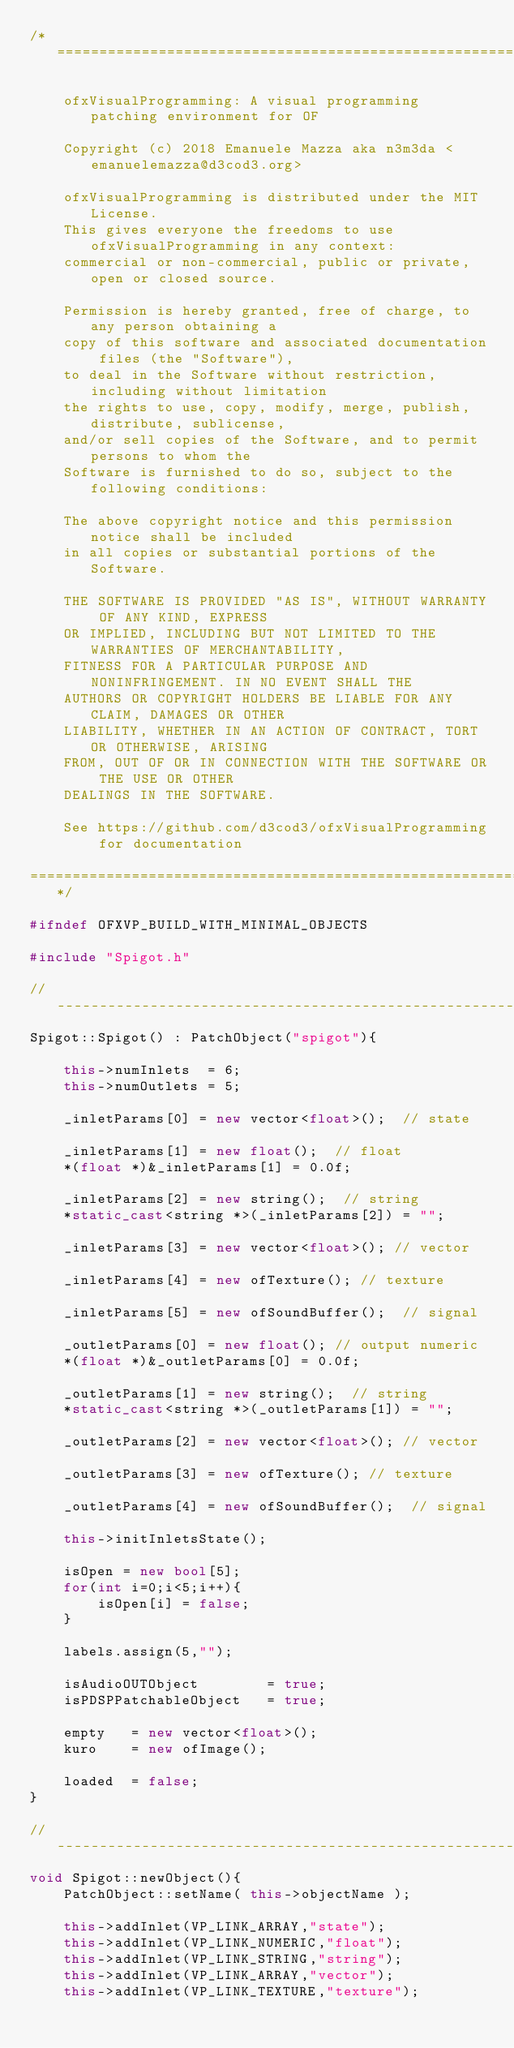<code> <loc_0><loc_0><loc_500><loc_500><_C++_>/*==============================================================================

    ofxVisualProgramming: A visual programming patching environment for OF

    Copyright (c) 2018 Emanuele Mazza aka n3m3da <emanuelemazza@d3cod3.org>

    ofxVisualProgramming is distributed under the MIT License.
    This gives everyone the freedoms to use ofxVisualProgramming in any context:
    commercial or non-commercial, public or private, open or closed source.

    Permission is hereby granted, free of charge, to any person obtaining a
    copy of this software and associated documentation files (the "Software"),
    to deal in the Software without restriction, including without limitation
    the rights to use, copy, modify, merge, publish, distribute, sublicense,
    and/or sell copies of the Software, and to permit persons to whom the
    Software is furnished to do so, subject to the following conditions:

    The above copyright notice and this permission notice shall be included
    in all copies or substantial portions of the Software.

    THE SOFTWARE IS PROVIDED "AS IS", WITHOUT WARRANTY OF ANY KIND, EXPRESS
    OR IMPLIED, INCLUDING BUT NOT LIMITED TO THE WARRANTIES OF MERCHANTABILITY,
    FITNESS FOR A PARTICULAR PURPOSE AND NONINFRINGEMENT. IN NO EVENT SHALL THE
    AUTHORS OR COPYRIGHT HOLDERS BE LIABLE FOR ANY CLAIM, DAMAGES OR OTHER
    LIABILITY, WHETHER IN AN ACTION OF CONTRACT, TORT OR OTHERWISE, ARISING
    FROM, OUT OF OR IN CONNECTION WITH THE SOFTWARE OR THE USE OR OTHER
    DEALINGS IN THE SOFTWARE.

    See https://github.com/d3cod3/ofxVisualProgramming for documentation

==============================================================================*/

#ifndef OFXVP_BUILD_WITH_MINIMAL_OBJECTS

#include "Spigot.h"

//--------------------------------------------------------------
Spigot::Spigot() : PatchObject("spigot"){

    this->numInlets  = 6;
    this->numOutlets = 5;

    _inletParams[0] = new vector<float>();  // state

    _inletParams[1] = new float();  // float
    *(float *)&_inletParams[1] = 0.0f;

    _inletParams[2] = new string();  // string
    *static_cast<string *>(_inletParams[2]) = "";

    _inletParams[3] = new vector<float>(); // vector

    _inletParams[4] = new ofTexture(); // texture

    _inletParams[5] = new ofSoundBuffer();  // signal

    _outletParams[0] = new float(); // output numeric
    *(float *)&_outletParams[0] = 0.0f;

    _outletParams[1] = new string();  // string
    *static_cast<string *>(_outletParams[1]) = "";

    _outletParams[2] = new vector<float>(); // vector

    _outletParams[3] = new ofTexture(); // texture

    _outletParams[4] = new ofSoundBuffer();  // signal

    this->initInletsState();

    isOpen = new bool[5];
    for(int i=0;i<5;i++){
        isOpen[i] = false;
    }

    labels.assign(5,"");

    isAudioOUTObject        = true;
    isPDSPPatchableObject   = true;

    empty   = new vector<float>();
    kuro    = new ofImage();

    loaded  = false;
}

//--------------------------------------------------------------
void Spigot::newObject(){
    PatchObject::setName( this->objectName );

    this->addInlet(VP_LINK_ARRAY,"state");
    this->addInlet(VP_LINK_NUMERIC,"float");
    this->addInlet(VP_LINK_STRING,"string");
    this->addInlet(VP_LINK_ARRAY,"vector");
    this->addInlet(VP_LINK_TEXTURE,"texture");</code> 